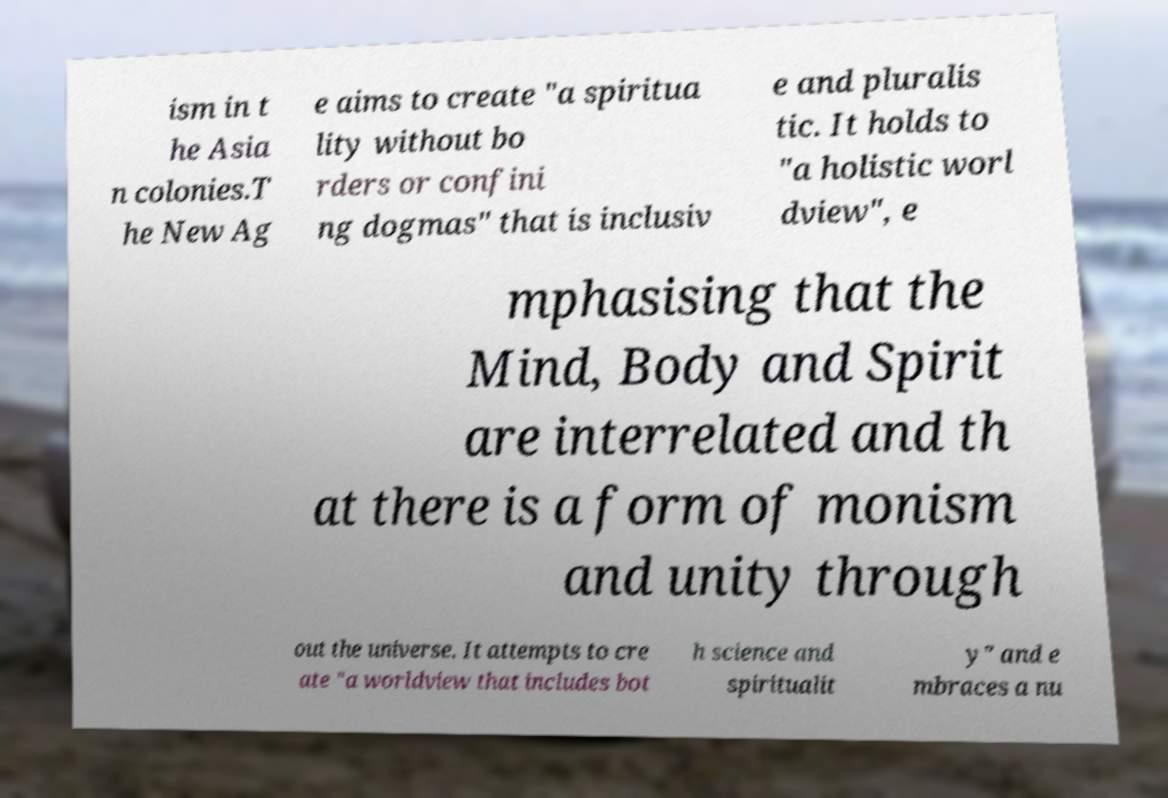Can you accurately transcribe the text from the provided image for me? ism in t he Asia n colonies.T he New Ag e aims to create "a spiritua lity without bo rders or confini ng dogmas" that is inclusiv e and pluralis tic. It holds to "a holistic worl dview", e mphasising that the Mind, Body and Spirit are interrelated and th at there is a form of monism and unity through out the universe. It attempts to cre ate "a worldview that includes bot h science and spiritualit y" and e mbraces a nu 